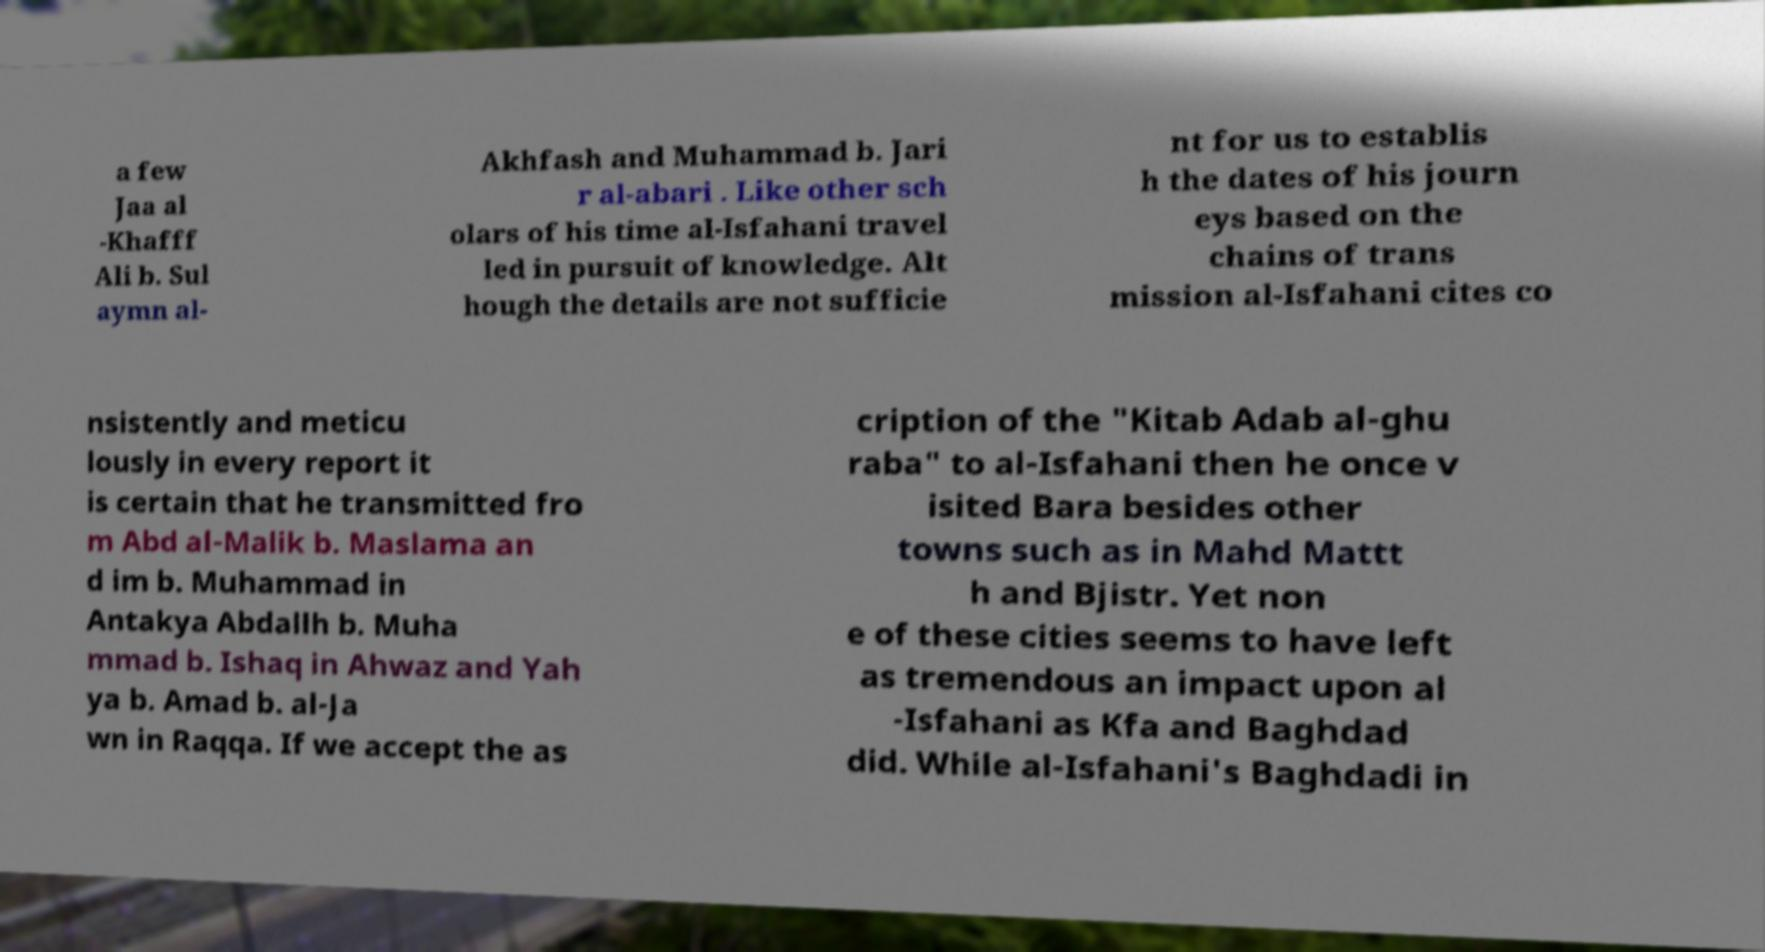Can you read and provide the text displayed in the image?This photo seems to have some interesting text. Can you extract and type it out for me? a few Jaa al -Khafff Ali b. Sul aymn al- Akhfash and Muhammad b. Jari r al-abari . Like other sch olars of his time al-Isfahani travel led in pursuit of knowledge. Alt hough the details are not sufficie nt for us to establis h the dates of his journ eys based on the chains of trans mission al-Isfahani cites co nsistently and meticu lously in every report it is certain that he transmitted fro m Abd al-Malik b. Maslama an d im b. Muhammad in Antakya Abdallh b. Muha mmad b. Ishaq in Ahwaz and Yah ya b. Amad b. al-Ja wn in Raqqa. If we accept the as cription of the "Kitab Adab al-ghu raba" to al-Isfahani then he once v isited Bara besides other towns such as in Mahd Mattt h and Bjistr. Yet non e of these cities seems to have left as tremendous an impact upon al -Isfahani as Kfa and Baghdad did. While al-Isfahani's Baghdadi in 